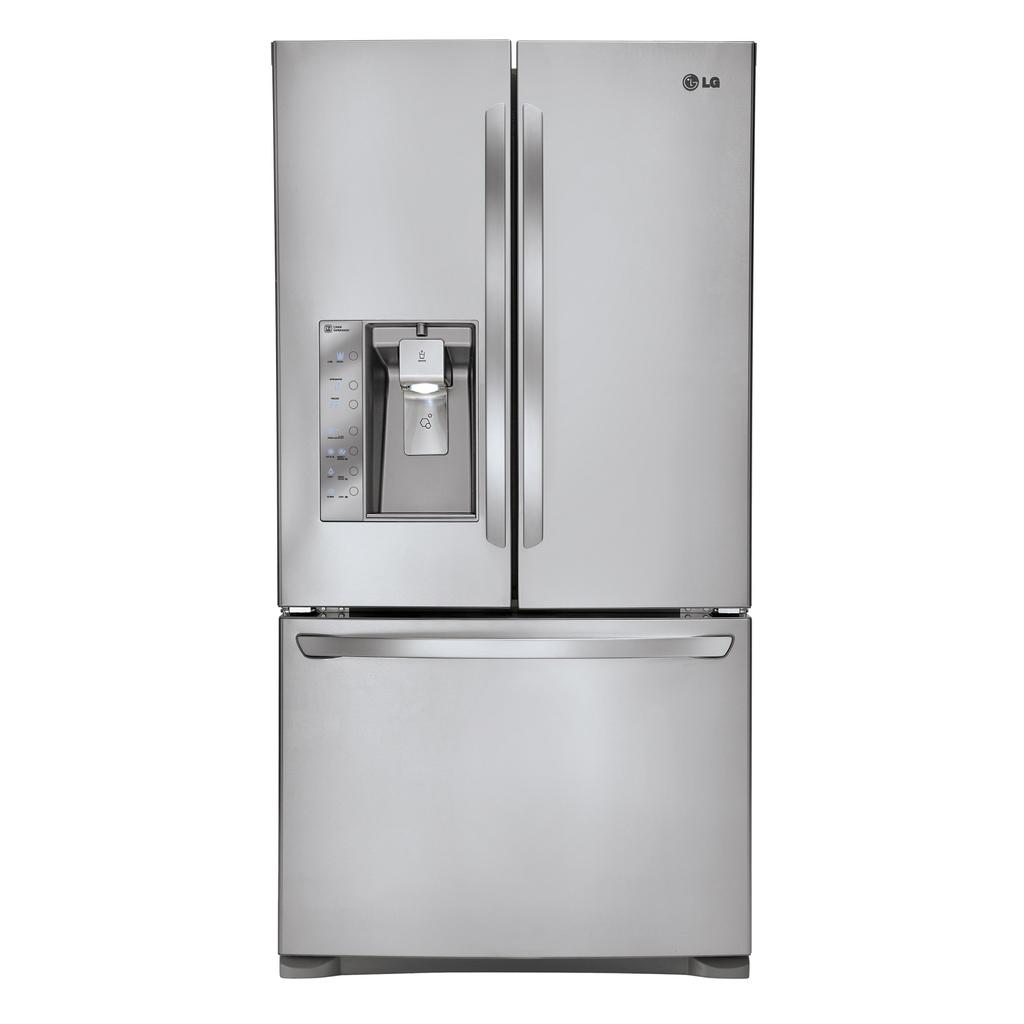What brand of fridge is that?
Offer a very short reply. Lg. 